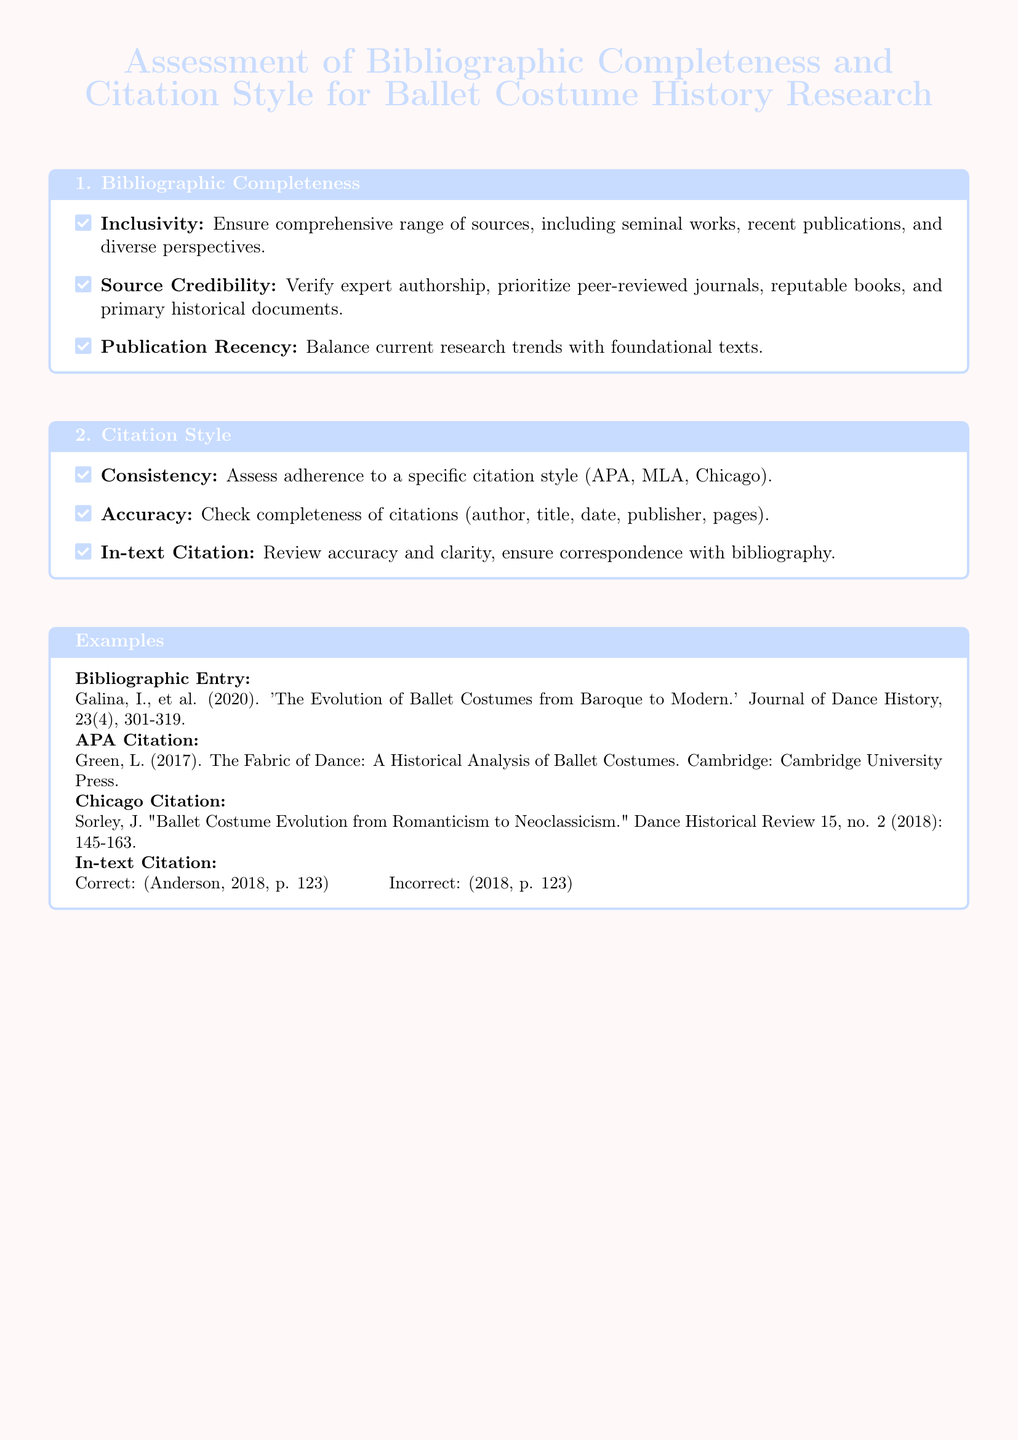What is the primary focus of the document? The document assesses the bibliographic completeness and citation style for ballet costume history research.
Answer: Ballet costume history research How many key areas are assessed in the document? The document has two main areas of assessment: bibliographic completeness and citation style.
Answer: Two What is the color used for the title text? The title text color is defined as ballet blue in the document.
Answer: Ballet blue Which citation style is mentioned first in the citation style section? The citation styles mentioned are in the order of consistency, accuracy, and in-text citation; consistency is first.
Answer: Consistency What year was the bibliographic entry by Galina published? The bibliographic entry provided mentions that it was published in the year 2020.
Answer: 2020 What publication describes a historical analysis of ballet costumes? The citation provided mentions "The Fabric of Dance: A Historical Analysis of Ballet Costumes."
Answer: The Fabric of Dance Which specific element is crucial for verifying source credibility? The document emphasizes the importance of expert authorship in confirming source credibility.
Answer: Expert authorship What should be ensured regarding in-text citations? In-text citations should be accurate and clear, ensuring correspondence with the bibliography.
Answer: Accurate and clear 